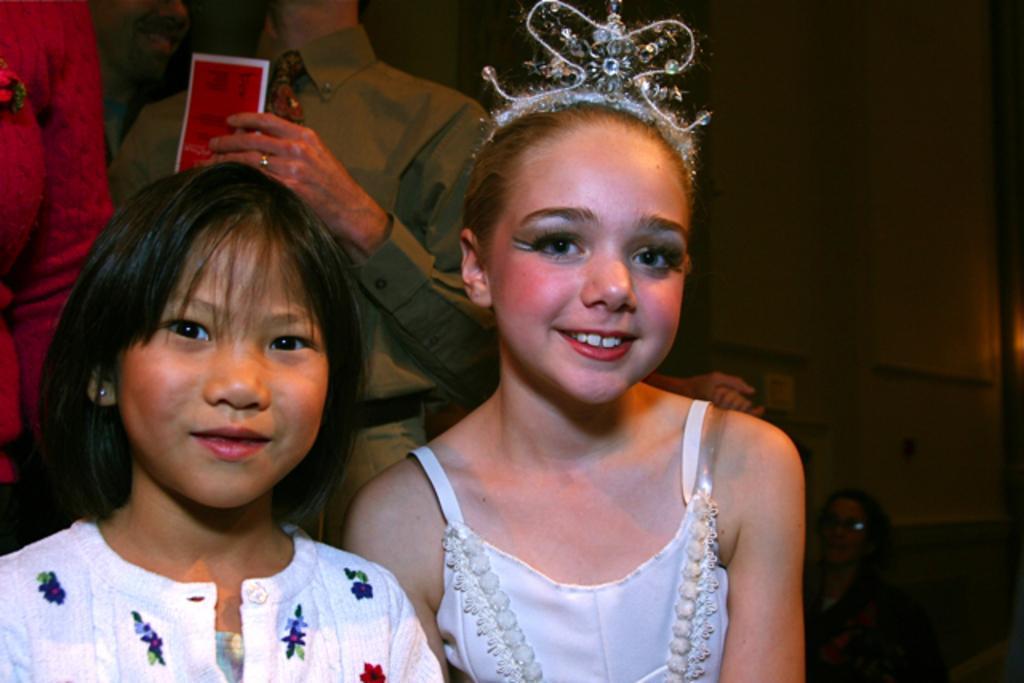In one or two sentences, can you explain what this image depicts? In this image I can see group of people standing. In front the person is wearing white color dress, background the other person is wearing brown color dress and holding a red color paper and I can see dark background. 